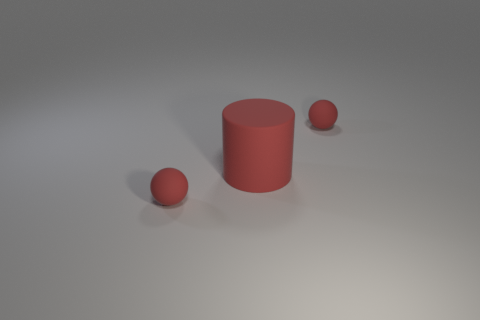Add 3 large matte cylinders. How many objects exist? 6 Subtract 0 purple blocks. How many objects are left? 3 Subtract all balls. How many objects are left? 1 Subtract all blue spheres. Subtract all cyan cylinders. How many spheres are left? 2 Subtract all brown cylinders. How many blue balls are left? 0 Subtract all tiny yellow cubes. Subtract all matte cylinders. How many objects are left? 2 Add 1 big matte cylinders. How many big matte cylinders are left? 2 Add 2 small red objects. How many small red objects exist? 4 